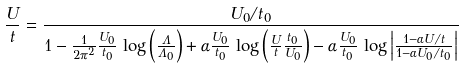<formula> <loc_0><loc_0><loc_500><loc_500>\frac { U } { t } = \frac { U _ { 0 } / t _ { 0 } } { 1 - \frac { 1 } { 2 \pi ^ { 2 } } \frac { U _ { 0 } } { t _ { 0 } } \, \log \left ( \frac { \Lambda } { \Lambda _ { 0 } } \right ) + \alpha \frac { U _ { 0 } } { t _ { 0 } } \, \log \left ( \frac { U } { t } \frac { t _ { 0 } } { U _ { 0 } } \right ) - \alpha \frac { U _ { 0 } } { t _ { 0 } } \, \log \left | \frac { 1 - \alpha U / t } { 1 - \alpha U _ { 0 } / t _ { 0 } } \right | }</formula> 